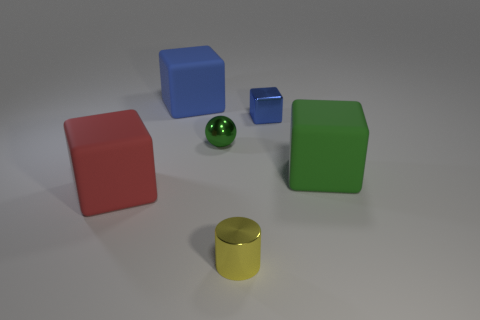Subtract 1 cubes. How many cubes are left? 3 Add 2 tiny metallic balls. How many objects exist? 8 Subtract all spheres. How many objects are left? 5 Subtract all green metallic spheres. Subtract all large blue matte cubes. How many objects are left? 4 Add 6 tiny shiny things. How many tiny shiny things are left? 9 Add 3 big yellow rubber cubes. How many big yellow rubber cubes exist? 3 Subtract 0 cyan spheres. How many objects are left? 6 